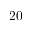Convert formula to latex. <formula><loc_0><loc_0><loc_500><loc_500>2 0</formula> 